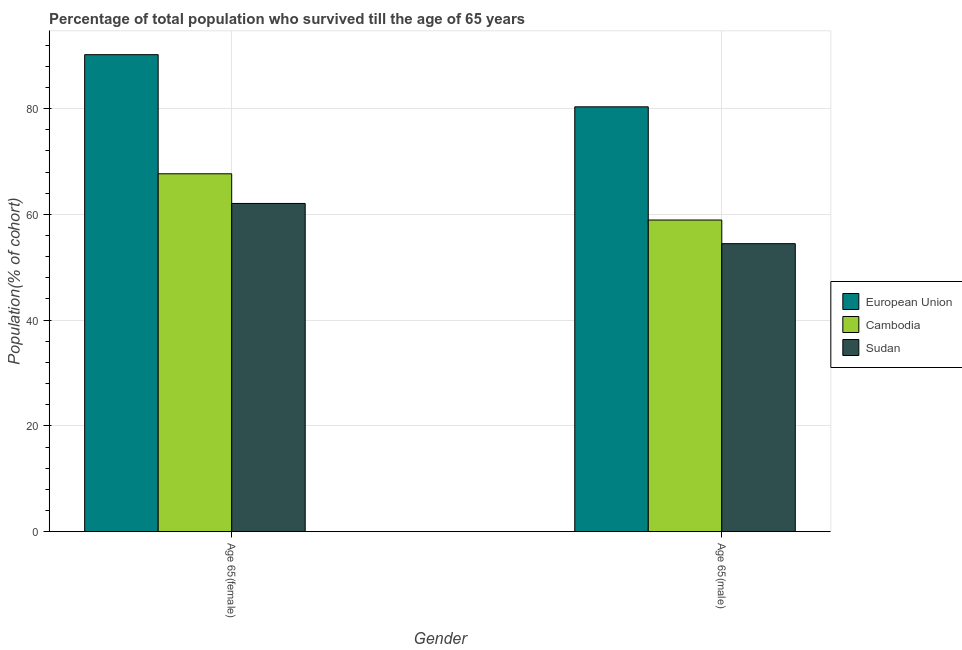How many groups of bars are there?
Ensure brevity in your answer.  2. Are the number of bars per tick equal to the number of legend labels?
Ensure brevity in your answer.  Yes. Are the number of bars on each tick of the X-axis equal?
Ensure brevity in your answer.  Yes. What is the label of the 1st group of bars from the left?
Offer a very short reply. Age 65(female). What is the percentage of male population who survived till age of 65 in European Union?
Make the answer very short. 80.33. Across all countries, what is the maximum percentage of female population who survived till age of 65?
Keep it short and to the point. 90.19. Across all countries, what is the minimum percentage of female population who survived till age of 65?
Ensure brevity in your answer.  62.07. In which country was the percentage of male population who survived till age of 65 minimum?
Provide a succinct answer. Sudan. What is the total percentage of male population who survived till age of 65 in the graph?
Your answer should be compact. 193.72. What is the difference between the percentage of female population who survived till age of 65 in Sudan and that in European Union?
Ensure brevity in your answer.  -28.13. What is the difference between the percentage of female population who survived till age of 65 in Sudan and the percentage of male population who survived till age of 65 in Cambodia?
Keep it short and to the point. 3.13. What is the average percentage of male population who survived till age of 65 per country?
Offer a very short reply. 64.57. What is the difference between the percentage of female population who survived till age of 65 and percentage of male population who survived till age of 65 in European Union?
Keep it short and to the point. 9.86. What is the ratio of the percentage of male population who survived till age of 65 in Sudan to that in European Union?
Offer a terse response. 0.68. In how many countries, is the percentage of female population who survived till age of 65 greater than the average percentage of female population who survived till age of 65 taken over all countries?
Offer a very short reply. 1. What does the 1st bar from the right in Age 65(male) represents?
Offer a terse response. Sudan. Are all the bars in the graph horizontal?
Provide a short and direct response. No. How many legend labels are there?
Ensure brevity in your answer.  3. How are the legend labels stacked?
Provide a short and direct response. Vertical. What is the title of the graph?
Your response must be concise. Percentage of total population who survived till the age of 65 years. What is the label or title of the Y-axis?
Offer a very short reply. Population(% of cohort). What is the Population(% of cohort) in European Union in Age 65(female)?
Provide a short and direct response. 90.19. What is the Population(% of cohort) of Cambodia in Age 65(female)?
Offer a terse response. 67.67. What is the Population(% of cohort) in Sudan in Age 65(female)?
Provide a short and direct response. 62.07. What is the Population(% of cohort) in European Union in Age 65(male)?
Provide a succinct answer. 80.33. What is the Population(% of cohort) in Cambodia in Age 65(male)?
Provide a succinct answer. 58.93. What is the Population(% of cohort) of Sudan in Age 65(male)?
Your answer should be compact. 54.46. Across all Gender, what is the maximum Population(% of cohort) in European Union?
Provide a short and direct response. 90.19. Across all Gender, what is the maximum Population(% of cohort) in Cambodia?
Your answer should be very brief. 67.67. Across all Gender, what is the maximum Population(% of cohort) in Sudan?
Provide a short and direct response. 62.07. Across all Gender, what is the minimum Population(% of cohort) of European Union?
Provide a succinct answer. 80.33. Across all Gender, what is the minimum Population(% of cohort) of Cambodia?
Keep it short and to the point. 58.93. Across all Gender, what is the minimum Population(% of cohort) in Sudan?
Offer a terse response. 54.46. What is the total Population(% of cohort) in European Union in the graph?
Offer a terse response. 170.52. What is the total Population(% of cohort) in Cambodia in the graph?
Your answer should be very brief. 126.6. What is the total Population(% of cohort) of Sudan in the graph?
Your response must be concise. 116.53. What is the difference between the Population(% of cohort) in European Union in Age 65(female) and that in Age 65(male)?
Provide a succinct answer. 9.86. What is the difference between the Population(% of cohort) of Cambodia in Age 65(female) and that in Age 65(male)?
Keep it short and to the point. 8.74. What is the difference between the Population(% of cohort) of Sudan in Age 65(female) and that in Age 65(male)?
Your answer should be very brief. 7.61. What is the difference between the Population(% of cohort) of European Union in Age 65(female) and the Population(% of cohort) of Cambodia in Age 65(male)?
Keep it short and to the point. 31.26. What is the difference between the Population(% of cohort) in European Union in Age 65(female) and the Population(% of cohort) in Sudan in Age 65(male)?
Provide a short and direct response. 35.73. What is the difference between the Population(% of cohort) of Cambodia in Age 65(female) and the Population(% of cohort) of Sudan in Age 65(male)?
Give a very brief answer. 13.21. What is the average Population(% of cohort) in European Union per Gender?
Ensure brevity in your answer.  85.26. What is the average Population(% of cohort) of Cambodia per Gender?
Provide a succinct answer. 63.3. What is the average Population(% of cohort) of Sudan per Gender?
Your response must be concise. 58.26. What is the difference between the Population(% of cohort) of European Union and Population(% of cohort) of Cambodia in Age 65(female)?
Keep it short and to the point. 22.52. What is the difference between the Population(% of cohort) in European Union and Population(% of cohort) in Sudan in Age 65(female)?
Give a very brief answer. 28.13. What is the difference between the Population(% of cohort) of Cambodia and Population(% of cohort) of Sudan in Age 65(female)?
Provide a short and direct response. 5.61. What is the difference between the Population(% of cohort) of European Union and Population(% of cohort) of Cambodia in Age 65(male)?
Your answer should be compact. 21.4. What is the difference between the Population(% of cohort) of European Union and Population(% of cohort) of Sudan in Age 65(male)?
Give a very brief answer. 25.87. What is the difference between the Population(% of cohort) in Cambodia and Population(% of cohort) in Sudan in Age 65(male)?
Keep it short and to the point. 4.47. What is the ratio of the Population(% of cohort) in European Union in Age 65(female) to that in Age 65(male)?
Provide a succinct answer. 1.12. What is the ratio of the Population(% of cohort) of Cambodia in Age 65(female) to that in Age 65(male)?
Give a very brief answer. 1.15. What is the ratio of the Population(% of cohort) in Sudan in Age 65(female) to that in Age 65(male)?
Offer a very short reply. 1.14. What is the difference between the highest and the second highest Population(% of cohort) in European Union?
Provide a short and direct response. 9.86. What is the difference between the highest and the second highest Population(% of cohort) in Cambodia?
Give a very brief answer. 8.74. What is the difference between the highest and the second highest Population(% of cohort) in Sudan?
Give a very brief answer. 7.61. What is the difference between the highest and the lowest Population(% of cohort) in European Union?
Keep it short and to the point. 9.86. What is the difference between the highest and the lowest Population(% of cohort) of Cambodia?
Your answer should be compact. 8.74. What is the difference between the highest and the lowest Population(% of cohort) in Sudan?
Provide a short and direct response. 7.61. 